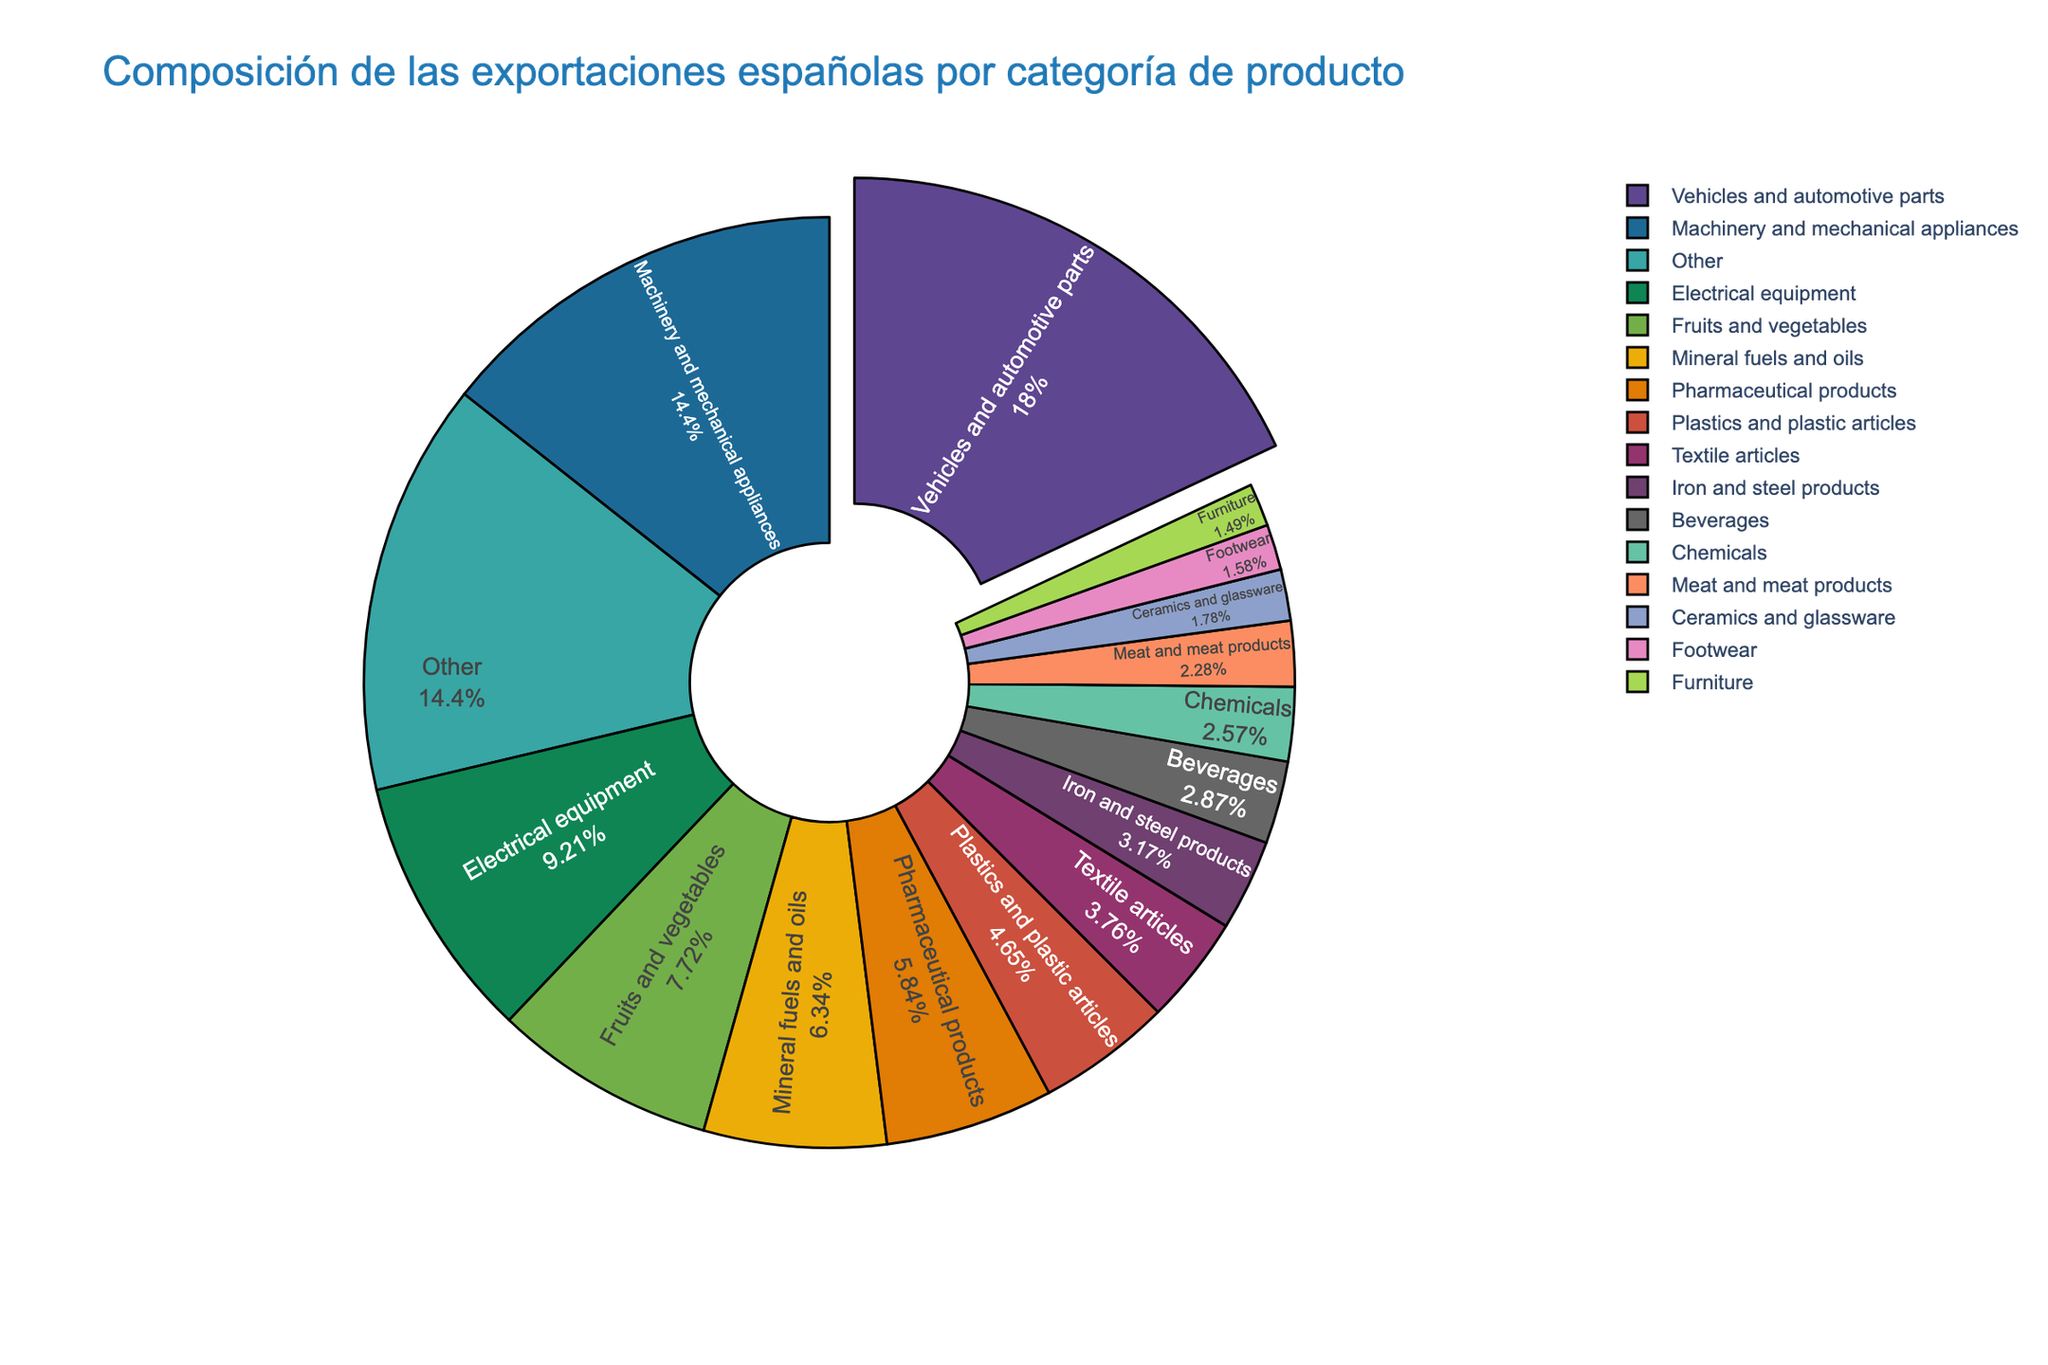What is the largest product category of Spain's exports? The figure shows that Vehicles and automotive parts have the biggest slice. By comparing the segments, this category is notably highlighted for its larger size.
Answer: Vehicles and automotive parts Which product category in Spain's exports has a total of 7.8%? Observe the pie chart for the category with the label "7.8%". The slice labeled Fruits and vegetables is the one assigned to 7.8%.
Answer: Fruits and vegetables What is the combined percentage of Machinery and mechanical appliances and Electrical equipment? Locate both categories in the pie chart. Machinery and mechanical appliances is 14.5%, and Electrical equipment is 9.3%. Add both values: 14.5% + 9.3% = 23.8%.
Answer: 23.8% Which product category is slightly smaller than Pharmacy products in Spain's exports? Compare the percentage slices of Pharmacy products at 5.9% with the adjacent smaller slices. Plastics and plastic articles at 4.7% is slightly smaller.
Answer: Plastics and plastic articles What is the difference in percentage between the largest and the smallest product categories? The largest category, Vehicles and automotive parts, is 18.2%. The smallest, Furniture, is 1.5%. Subtract to find the difference: 18.2% - 1.5% = 16.7%.
Answer: 16.7% Which product category in Spain's exports is represented with the color green? Identify the slice that is colored green. This corresponds to the Electrical equipment category.
Answer: Electrical equipment What is the relationship between the percentage of Textile articles and Footwear? The pie chart shows Textile articles at 3.8% and Footwear at 1.6%. Textile articles is 3.8 - 1.6 = 2.2% more than Footwear.
Answer: Textile articles are larger by 2.2% How many categories have a percentage greater than 10%? Count the product categories displayed with percentages greater than 10%. The categories are Vehicles and automotive parts (18.2%) and Machinery and mechanical appliances (14.5%).
Answer: 2 What percentage of Spain's exports do Iron and steel products and Beverages together account for? Locate Iron and steel products (3.2%) and Beverages (2.9%) on the chart. Add them up: 3.2% + 2.9% = 6.1%.
Answer: 6.1% Which segment occupies a position between 2% and 3%? Examine the pie chart for segments within the 2% - 3% range. Beverages (2.9%) and Meat and meat products (2.3%) are the only two in this range.
Answer: Beverages and Meat and meat products 